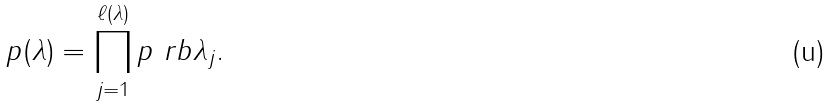Convert formula to latex. <formula><loc_0><loc_0><loc_500><loc_500>p ( \lambda ) = \prod _ { j = 1 } ^ { \ell ( \lambda ) } p \ r b { \lambda _ { j } } .</formula> 